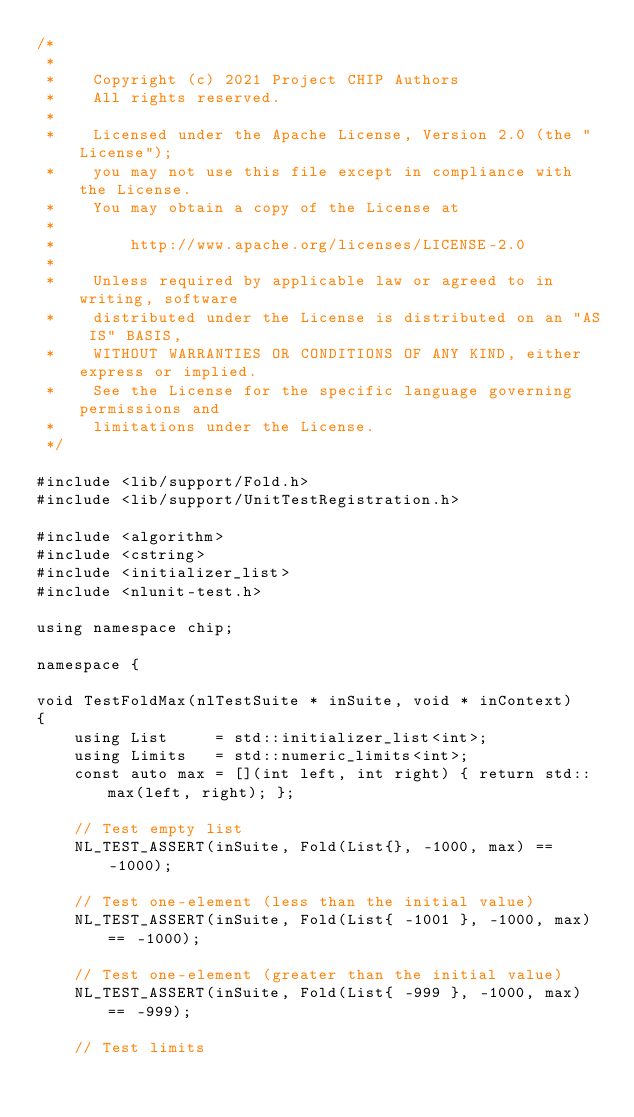Convert code to text. <code><loc_0><loc_0><loc_500><loc_500><_C++_>/*
 *
 *    Copyright (c) 2021 Project CHIP Authors
 *    All rights reserved.
 *
 *    Licensed under the Apache License, Version 2.0 (the "License");
 *    you may not use this file except in compliance with the License.
 *    You may obtain a copy of the License at
 *
 *        http://www.apache.org/licenses/LICENSE-2.0
 *
 *    Unless required by applicable law or agreed to in writing, software
 *    distributed under the License is distributed on an "AS IS" BASIS,
 *    WITHOUT WARRANTIES OR CONDITIONS OF ANY KIND, either express or implied.
 *    See the License for the specific language governing permissions and
 *    limitations under the License.
 */

#include <lib/support/Fold.h>
#include <lib/support/UnitTestRegistration.h>

#include <algorithm>
#include <cstring>
#include <initializer_list>
#include <nlunit-test.h>

using namespace chip;

namespace {

void TestFoldMax(nlTestSuite * inSuite, void * inContext)
{
    using List     = std::initializer_list<int>;
    using Limits   = std::numeric_limits<int>;
    const auto max = [](int left, int right) { return std::max(left, right); };

    // Test empty list
    NL_TEST_ASSERT(inSuite, Fold(List{}, -1000, max) == -1000);

    // Test one-element (less than the initial value)
    NL_TEST_ASSERT(inSuite, Fold(List{ -1001 }, -1000, max) == -1000);

    // Test one-element (greater than the initial value)
    NL_TEST_ASSERT(inSuite, Fold(List{ -999 }, -1000, max) == -999);

    // Test limits</code> 